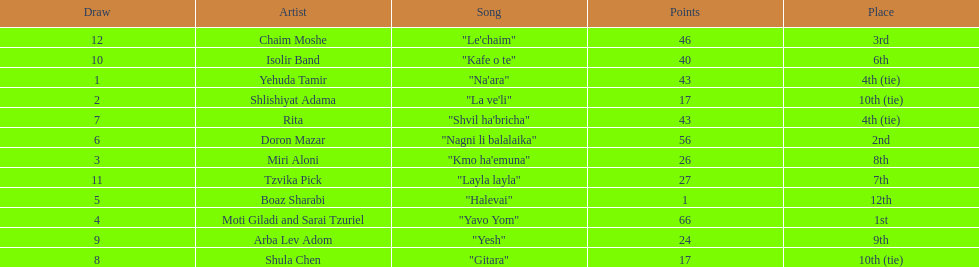Which artist had almost no points? Boaz Sharabi. 